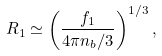<formula> <loc_0><loc_0><loc_500><loc_500>R _ { 1 } \simeq \left ( \frac { f _ { 1 } } { 4 \pi n _ { b } / 3 } \right ) ^ { 1 / 3 } ,</formula> 